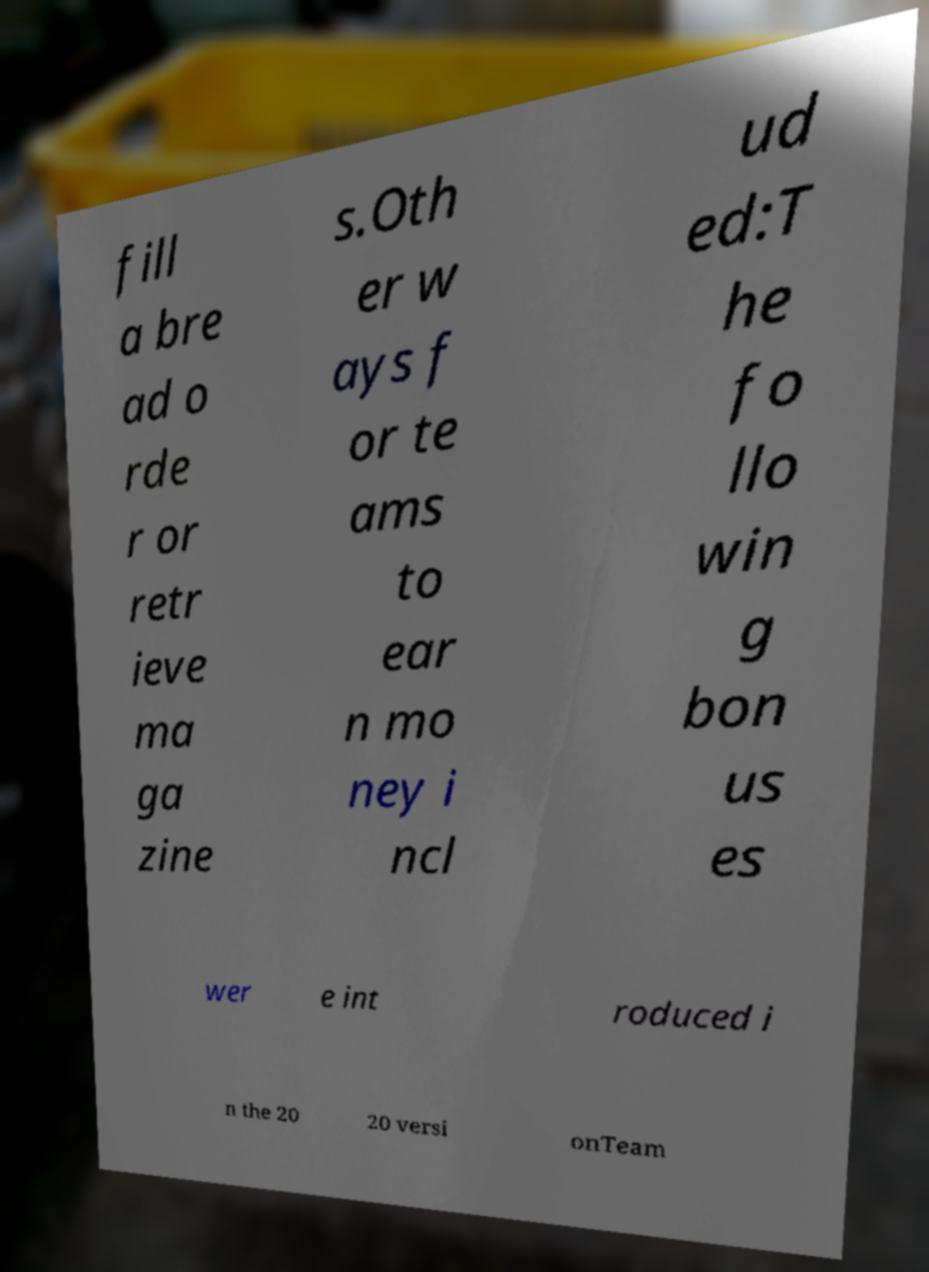Can you read and provide the text displayed in the image?This photo seems to have some interesting text. Can you extract and type it out for me? fill a bre ad o rde r or retr ieve ma ga zine s.Oth er w ays f or te ams to ear n mo ney i ncl ud ed:T he fo llo win g bon us es wer e int roduced i n the 20 20 versi onTeam 